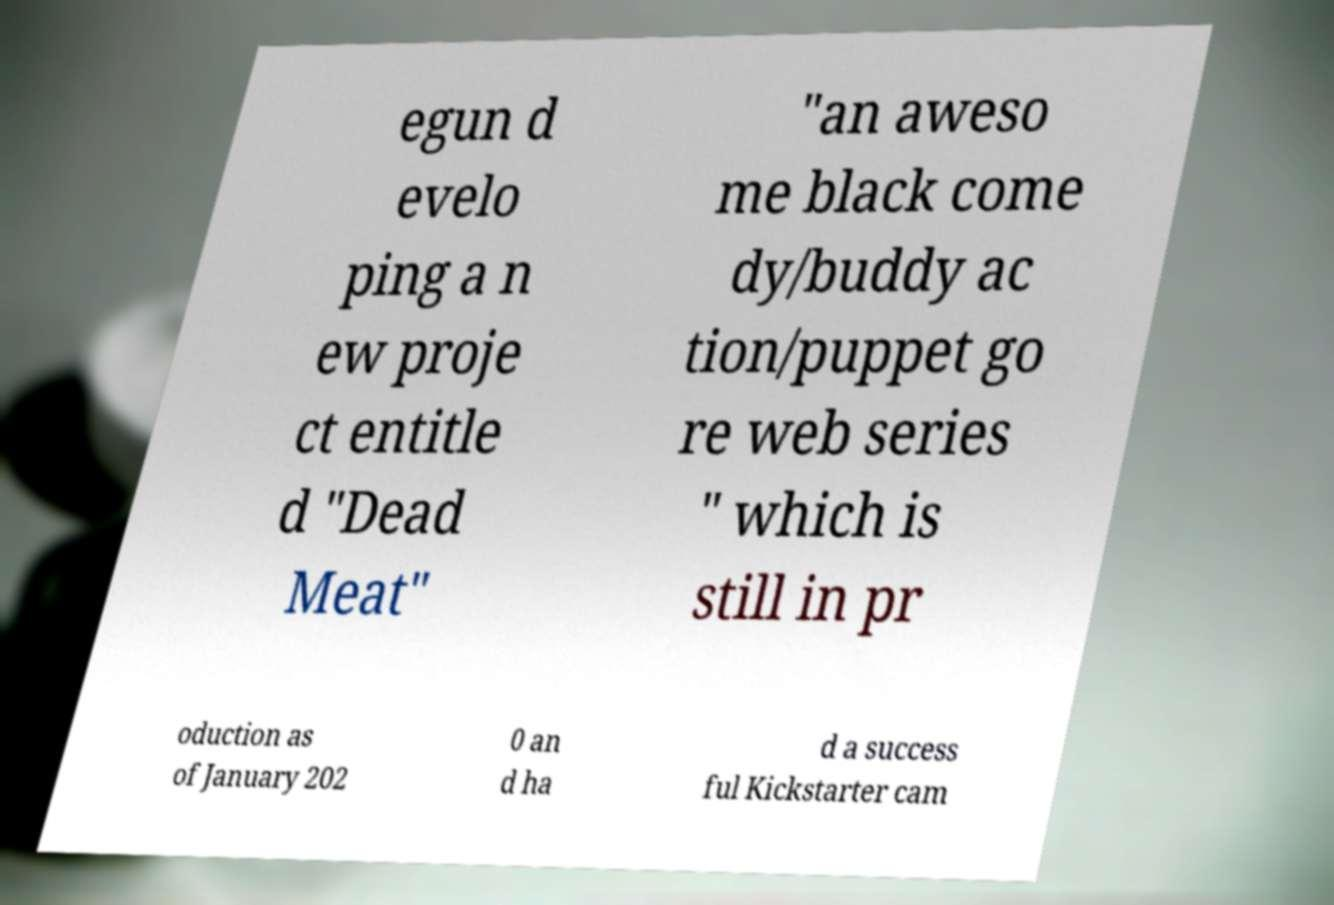Please read and relay the text visible in this image. What does it say? egun d evelo ping a n ew proje ct entitle d "Dead Meat" "an aweso me black come dy/buddy ac tion/puppet go re web series " which is still in pr oduction as of January 202 0 an d ha d a success ful Kickstarter cam 